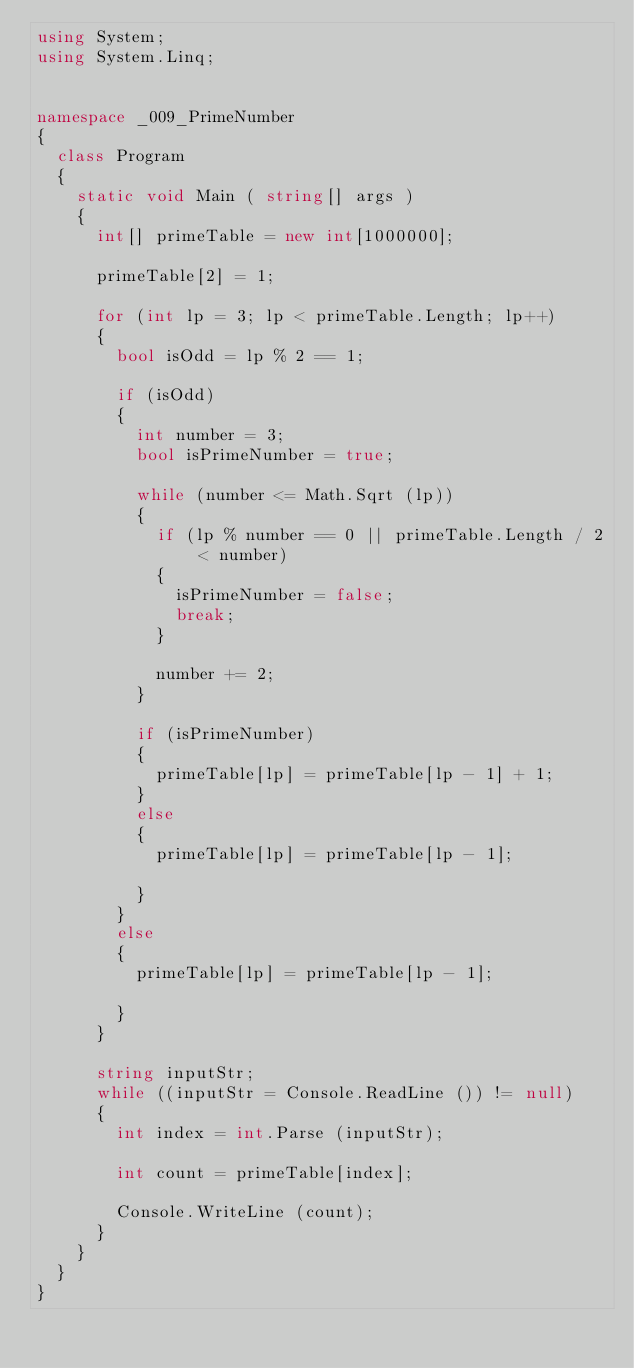<code> <loc_0><loc_0><loc_500><loc_500><_C#_>using System;
using System.Linq;


namespace _009_PrimeNumber
{
	class Program
	{
		static void Main ( string[] args )
		{
			int[] primeTable = new int[1000000];

			primeTable[2] = 1;

			for (int lp = 3; lp < primeTable.Length; lp++)
			{
				bool isOdd = lp % 2 == 1;

				if (isOdd)
				{
					int number = 3;
					bool isPrimeNumber = true;

					while (number <= Math.Sqrt (lp))
					{
						if (lp % number == 0 || primeTable.Length / 2 < number)
						{
							isPrimeNumber = false;
							break;
						}

						number += 2;
					}

					if (isPrimeNumber)
					{
						primeTable[lp] = primeTable[lp - 1] + 1;
					}
					else
					{
						primeTable[lp] = primeTable[lp - 1];						
					}
				}
				else
				{
					primeTable[lp] = primeTable[lp - 1];						
				}
			}

			string inputStr;
			while ((inputStr = Console.ReadLine ()) != null)
			{
				int index = int.Parse (inputStr);

				int count = primeTable[index];

				Console.WriteLine (count);
			}
		}
	}
}</code> 